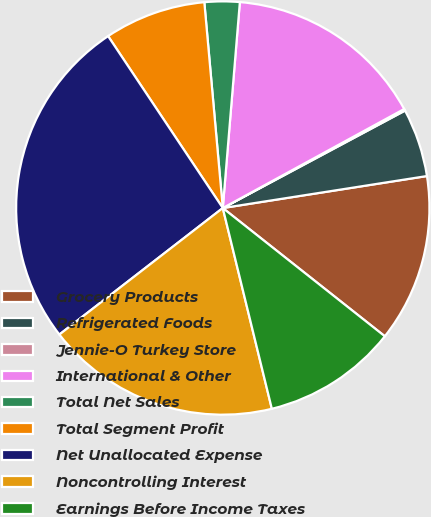Convert chart. <chart><loc_0><loc_0><loc_500><loc_500><pie_chart><fcel>Grocery Products<fcel>Refrigerated Foods<fcel>Jennie-O Turkey Store<fcel>International & Other<fcel>Total Net Sales<fcel>Total Segment Profit<fcel>Net Unallocated Expense<fcel>Noncontrolling Interest<fcel>Earnings Before Income Taxes<nl><fcel>13.13%<fcel>5.34%<fcel>0.14%<fcel>15.73%<fcel>2.74%<fcel>7.94%<fcel>26.12%<fcel>18.33%<fcel>10.53%<nl></chart> 